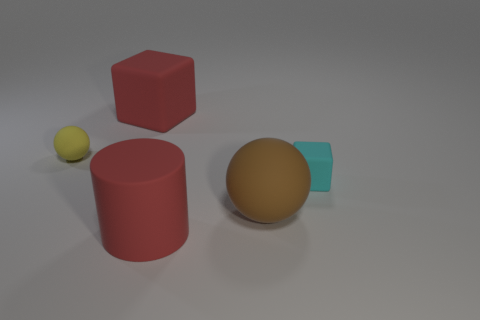How many other things are there of the same material as the big cylinder?
Your answer should be very brief. 4. The object that is both behind the red cylinder and in front of the small matte cube is what color?
Make the answer very short. Brown. Does the thing that is behind the yellow rubber sphere have the same size as the rubber cylinder?
Ensure brevity in your answer.  Yes. There is a big ball; does it have the same color as the small object on the left side of the cyan object?
Ensure brevity in your answer.  No. The matte object that is the same color as the rubber cylinder is what shape?
Keep it short and to the point. Cube. The tiny cyan object is what shape?
Make the answer very short. Cube. Do the small cube and the large matte cylinder have the same color?
Provide a short and direct response. No. What number of things are either yellow matte objects behind the cylinder or small yellow shiny spheres?
Your answer should be compact. 1. There is a cyan thing that is made of the same material as the small sphere; what size is it?
Offer a very short reply. Small. Is the number of small cyan objects left of the small cyan object greater than the number of purple shiny blocks?
Provide a succinct answer. No. 